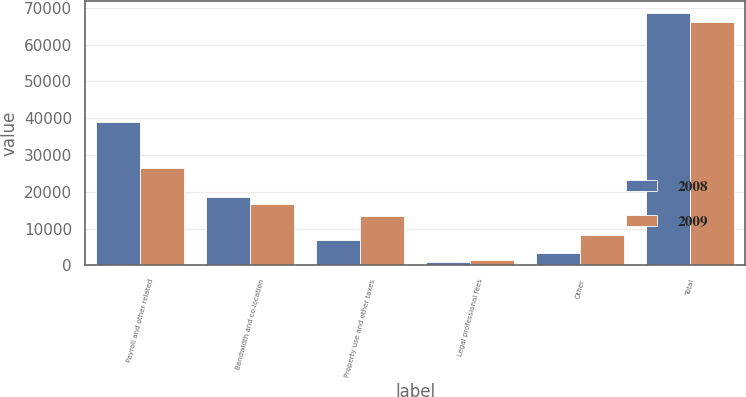Convert chart. <chart><loc_0><loc_0><loc_500><loc_500><stacked_bar_chart><ecel><fcel>Payroll and other related<fcel>Bandwidth and co-location<fcel>Property use and other taxes<fcel>Legal professional fees<fcel>Other<fcel>Total<nl><fcel>2008<fcel>38841<fcel>18591<fcel>6815<fcel>931<fcel>3388<fcel>68566<nl><fcel>2009<fcel>26377<fcel>16642<fcel>13317<fcel>1475<fcel>8321<fcel>66132<nl></chart> 